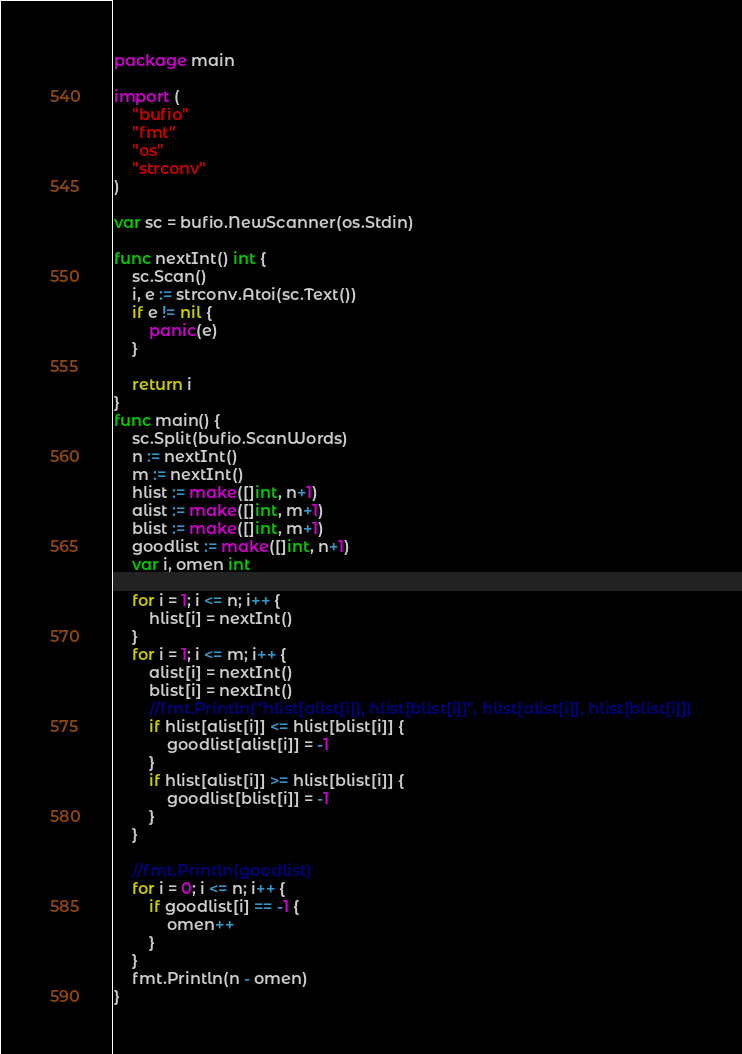Convert code to text. <code><loc_0><loc_0><loc_500><loc_500><_Go_>package main

import (
	"bufio"
	"fmt"
	"os"
	"strconv"
)

var sc = bufio.NewScanner(os.Stdin)

func nextInt() int {
	sc.Scan()
	i, e := strconv.Atoi(sc.Text())
	if e != nil {
		panic(e)
	}

	return i
}
func main() {
	sc.Split(bufio.ScanWords)
	n := nextInt()
	m := nextInt()
	hlist := make([]int, n+1)
	alist := make([]int, m+1)
	blist := make([]int, m+1)
	goodlist := make([]int, n+1)
	var i, omen int

	for i = 1; i <= n; i++ {
		hlist[i] = nextInt()
	}
	for i = 1; i <= m; i++ {
		alist[i] = nextInt()
		blist[i] = nextInt()
		//fmt.Println("hlist[alist[i]], hlist[blist[i]]", hlist[alist[i]], hlist[blist[i]])
		if hlist[alist[i]] <= hlist[blist[i]] {
			goodlist[alist[i]] = -1
		}
		if hlist[alist[i]] >= hlist[blist[i]] {
			goodlist[blist[i]] = -1
		}
	}

	//fmt.Println(goodlist)
	for i = 0; i <= n; i++ {
		if goodlist[i] == -1 {
			omen++
		}
	}
	fmt.Println(n - omen)
}
</code> 